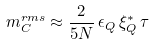<formula> <loc_0><loc_0><loc_500><loc_500>m _ { C } ^ { r m s } \approx \frac { 2 } { 5 N } \, \epsilon _ { Q } \, \xi _ { Q } ^ { * } \, \tau</formula> 